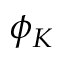Convert formula to latex. <formula><loc_0><loc_0><loc_500><loc_500>\phi _ { K }</formula> 